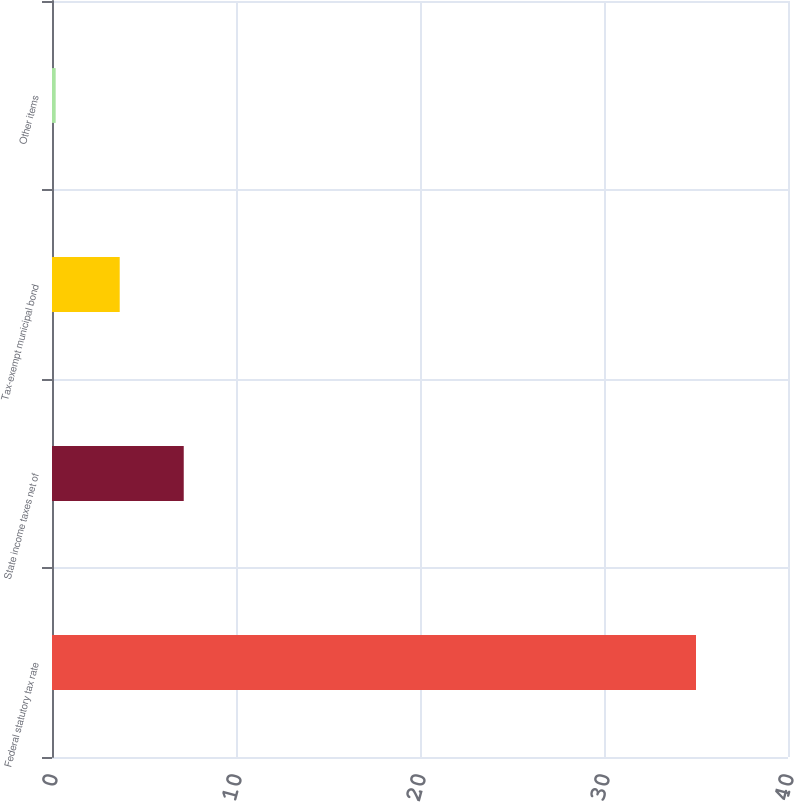Convert chart to OTSL. <chart><loc_0><loc_0><loc_500><loc_500><bar_chart><fcel>Federal statutory tax rate<fcel>State income taxes net of<fcel>Tax-exempt municipal bond<fcel>Other items<nl><fcel>35<fcel>7.16<fcel>3.68<fcel>0.2<nl></chart> 